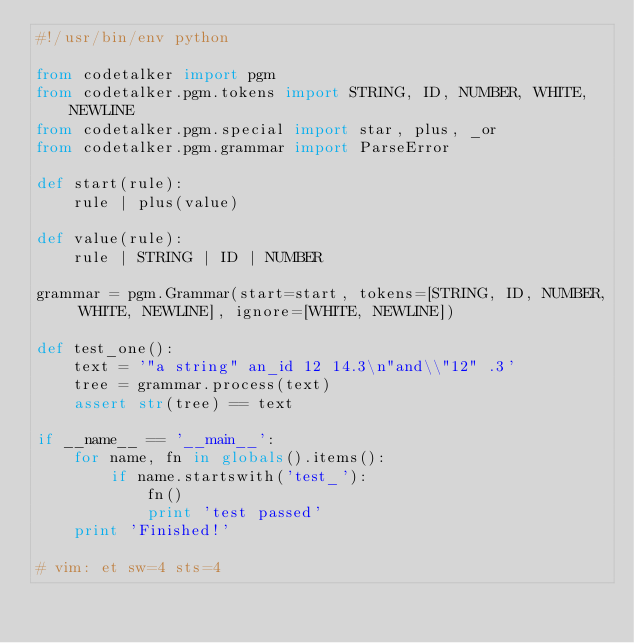Convert code to text. <code><loc_0><loc_0><loc_500><loc_500><_Python_>#!/usr/bin/env python

from codetalker import pgm
from codetalker.pgm.tokens import STRING, ID, NUMBER, WHITE, NEWLINE
from codetalker.pgm.special import star, plus, _or
from codetalker.pgm.grammar import ParseError

def start(rule):
    rule | plus(value)

def value(rule):
    rule | STRING | ID | NUMBER

grammar = pgm.Grammar(start=start, tokens=[STRING, ID, NUMBER, WHITE, NEWLINE], ignore=[WHITE, NEWLINE])

def test_one():
    text = '"a string" an_id 12 14.3\n"and\\"12" .3'
    tree = grammar.process(text)
    assert str(tree) == text

if __name__ == '__main__':
    for name, fn in globals().items():
        if name.startswith('test_'):
            fn()
            print 'test passed'
    print 'Finished!'

# vim: et sw=4 sts=4
</code> 